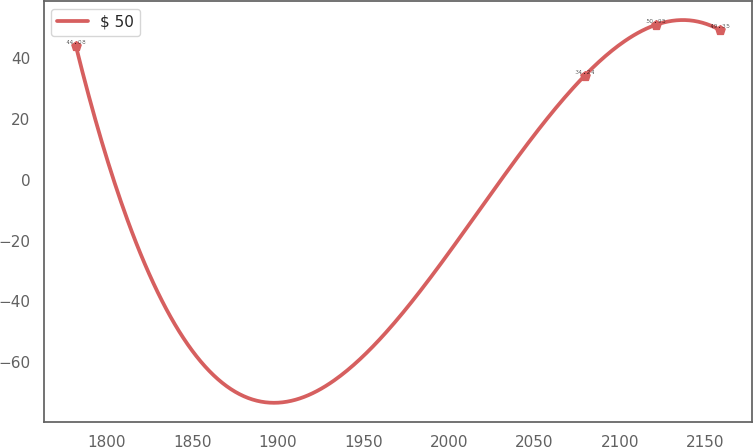Convert chart. <chart><loc_0><loc_0><loc_500><loc_500><line_chart><ecel><fcel>$ 50<nl><fcel>1781.82<fcel>44.08<nl><fcel>2079.42<fcel>34.24<nl><fcel>2120.9<fcel>50.95<nl><fcel>2158.35<fcel>49.35<nl></chart> 